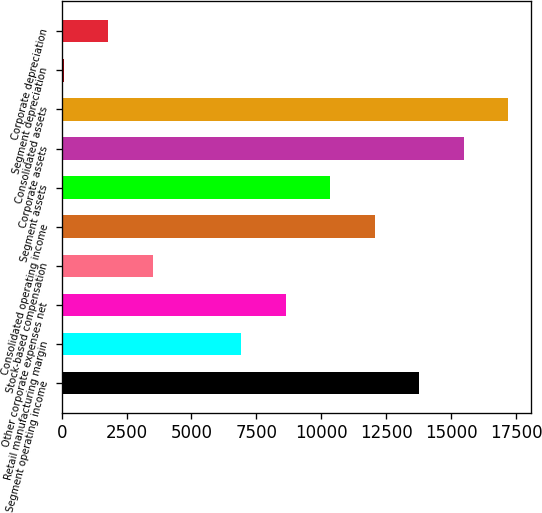Convert chart. <chart><loc_0><loc_0><loc_500><loc_500><bar_chart><fcel>Segment operating income<fcel>Retail manufacturing margin<fcel>Other corporate expenses net<fcel>Stock-based compensation<fcel>Consolidated operating income<fcel>Segment assets<fcel>Corporate assets<fcel>Consolidated assets<fcel>Segment depreciation<fcel>Corporate depreciation<nl><fcel>13779<fcel>6927<fcel>8640<fcel>3501<fcel>12066<fcel>10353<fcel>15492<fcel>17205<fcel>75<fcel>1788<nl></chart> 